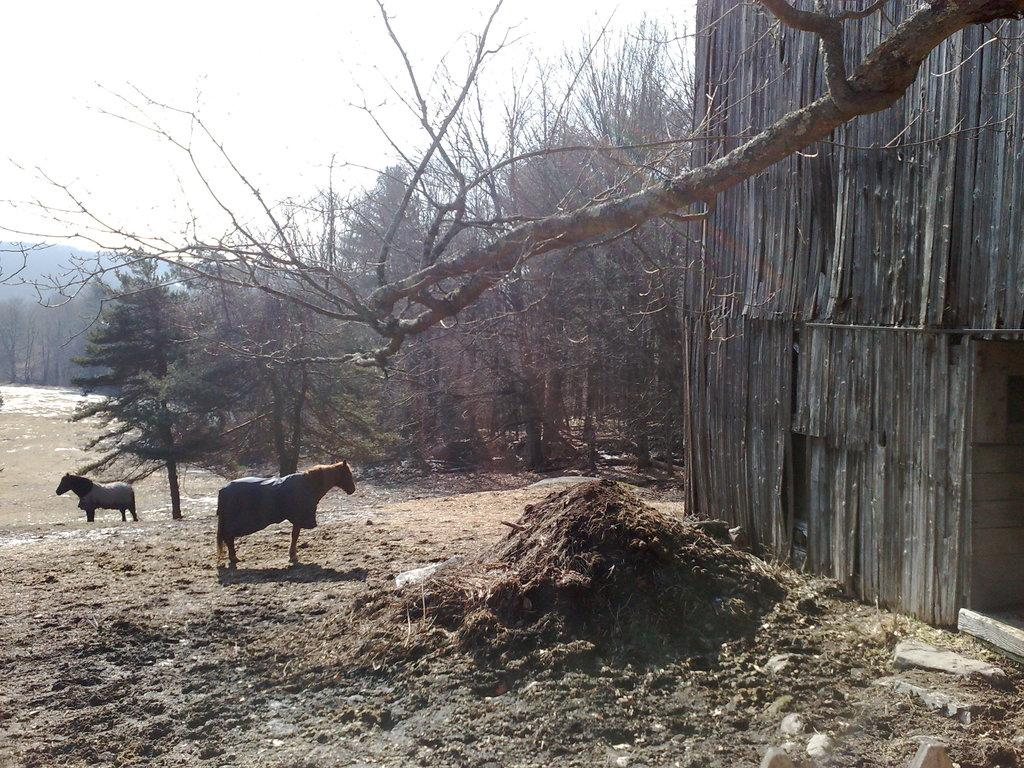How many horses are in the image? There are two horses in the image. Where are the horses located? The horses are on the ground. What can be seen in the background of the image? There are trees visible in the background of the image. What type of structure is present in the right corner of the image? There is a big wooden shed in the right corner of the image. How far apart are the horses' sisters in the image? There is no mention of the horses having sisters in the image, and therefore we cannot determine the distance between them. 